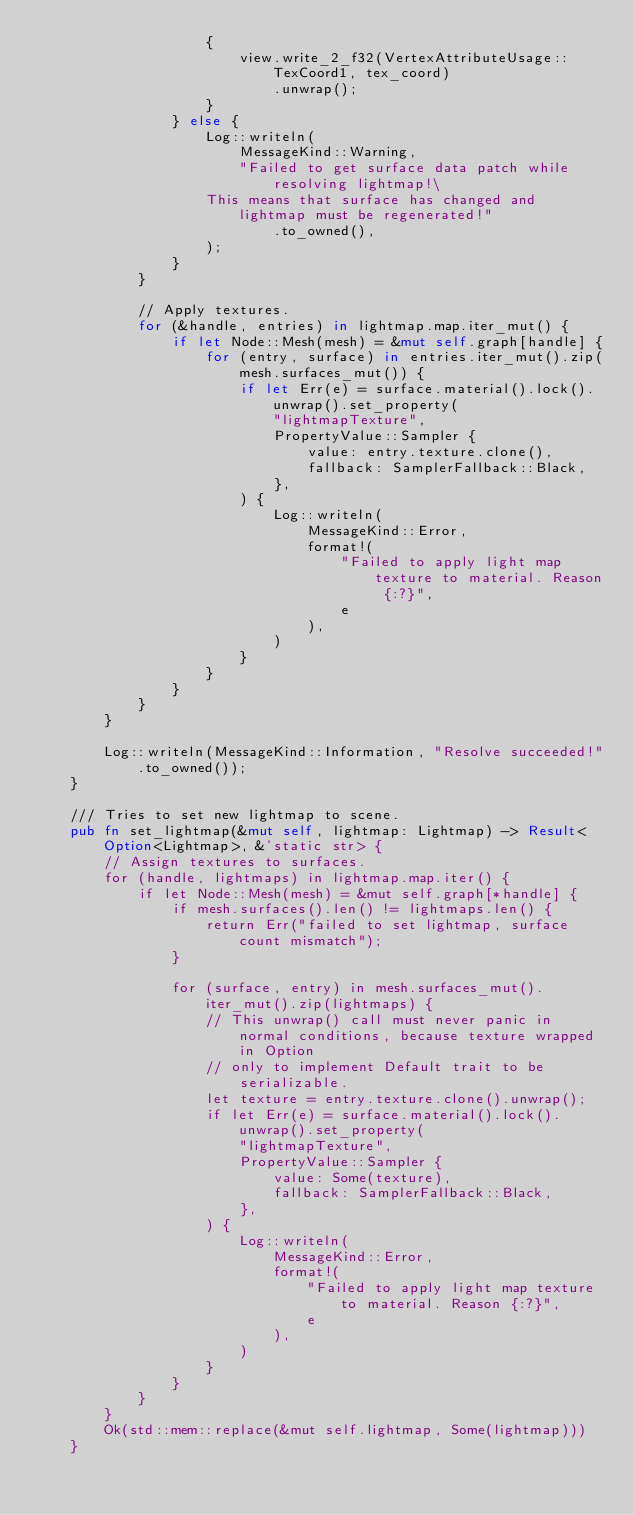Convert code to text. <code><loc_0><loc_0><loc_500><loc_500><_Rust_>                    {
                        view.write_2_f32(VertexAttributeUsage::TexCoord1, tex_coord)
                            .unwrap();
                    }
                } else {
                    Log::writeln(
                        MessageKind::Warning,
                        "Failed to get surface data patch while resolving lightmap!\
                    This means that surface has changed and lightmap must be regenerated!"
                            .to_owned(),
                    );
                }
            }

            // Apply textures.
            for (&handle, entries) in lightmap.map.iter_mut() {
                if let Node::Mesh(mesh) = &mut self.graph[handle] {
                    for (entry, surface) in entries.iter_mut().zip(mesh.surfaces_mut()) {
                        if let Err(e) = surface.material().lock().unwrap().set_property(
                            "lightmapTexture",
                            PropertyValue::Sampler {
                                value: entry.texture.clone(),
                                fallback: SamplerFallback::Black,
                            },
                        ) {
                            Log::writeln(
                                MessageKind::Error,
                                format!(
                                    "Failed to apply light map texture to material. Reason {:?}",
                                    e
                                ),
                            )
                        }
                    }
                }
            }
        }

        Log::writeln(MessageKind::Information, "Resolve succeeded!".to_owned());
    }

    /// Tries to set new lightmap to scene.
    pub fn set_lightmap(&mut self, lightmap: Lightmap) -> Result<Option<Lightmap>, &'static str> {
        // Assign textures to surfaces.
        for (handle, lightmaps) in lightmap.map.iter() {
            if let Node::Mesh(mesh) = &mut self.graph[*handle] {
                if mesh.surfaces().len() != lightmaps.len() {
                    return Err("failed to set lightmap, surface count mismatch");
                }

                for (surface, entry) in mesh.surfaces_mut().iter_mut().zip(lightmaps) {
                    // This unwrap() call must never panic in normal conditions, because texture wrapped in Option
                    // only to implement Default trait to be serializable.
                    let texture = entry.texture.clone().unwrap();
                    if let Err(e) = surface.material().lock().unwrap().set_property(
                        "lightmapTexture",
                        PropertyValue::Sampler {
                            value: Some(texture),
                            fallback: SamplerFallback::Black,
                        },
                    ) {
                        Log::writeln(
                            MessageKind::Error,
                            format!(
                                "Failed to apply light map texture to material. Reason {:?}",
                                e
                            ),
                        )
                    }
                }
            }
        }
        Ok(std::mem::replace(&mut self.lightmap, Some(lightmap)))
    }
</code> 